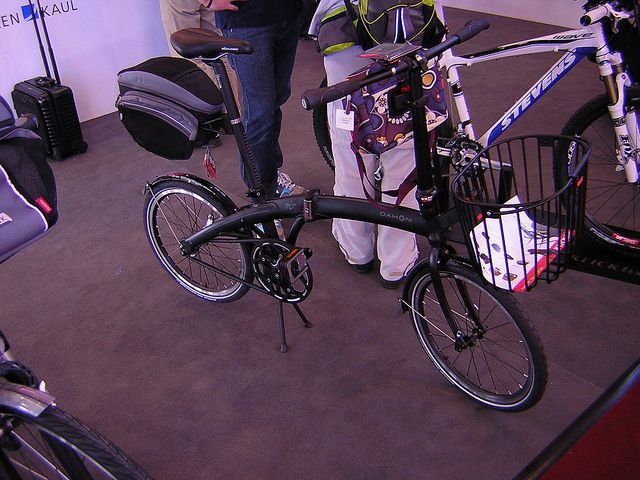<image>What is the purpose of the object in the basket? I am not sure about the purpose of the object in the basket. It can be for reading or holding stuff. What is the purpose of the object in the basket? I don't know the purpose of the object in the basket. It can be used to give information, reading, hold stuff or stop things from falling through. 